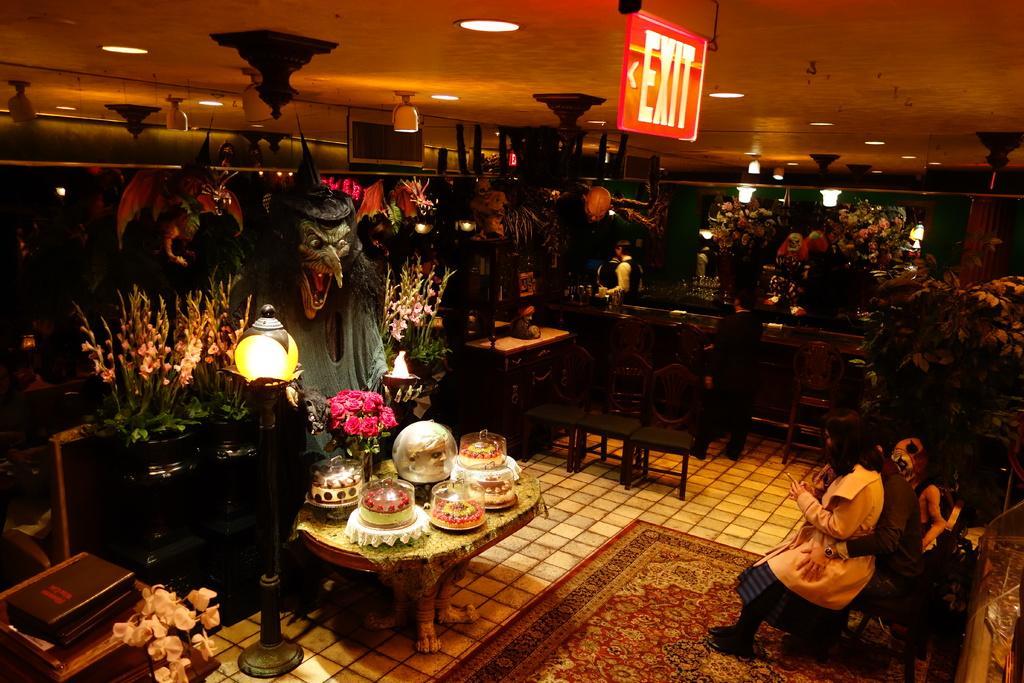Can you describe this image briefly? As we can see in the image there on the right side there are two people sitting on bench and there a dog. There are few plants here and there. On the left side there is a book, a table. On table there are some bowls and bouquet. There is a light over here and there are some few statues. 